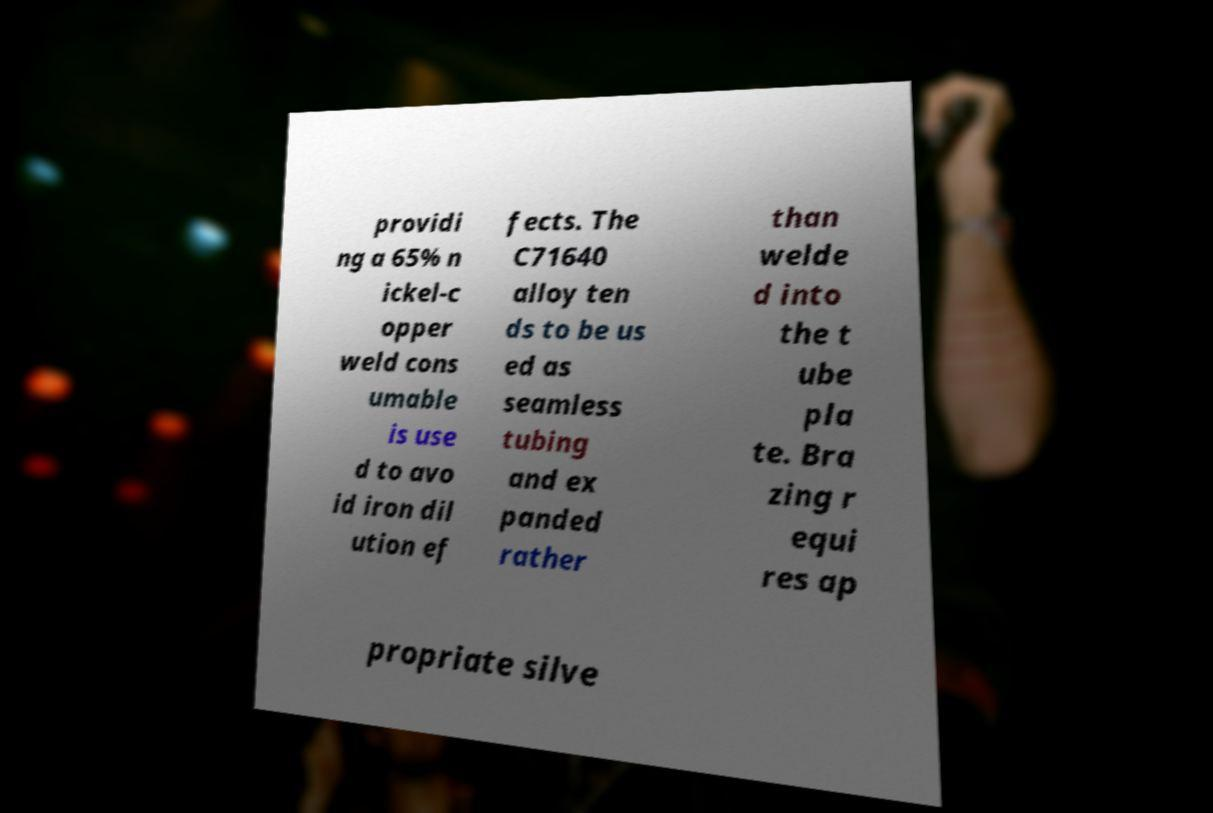I need the written content from this picture converted into text. Can you do that? providi ng a 65% n ickel-c opper weld cons umable is use d to avo id iron dil ution ef fects. The C71640 alloy ten ds to be us ed as seamless tubing and ex panded rather than welde d into the t ube pla te. Bra zing r equi res ap propriate silve 